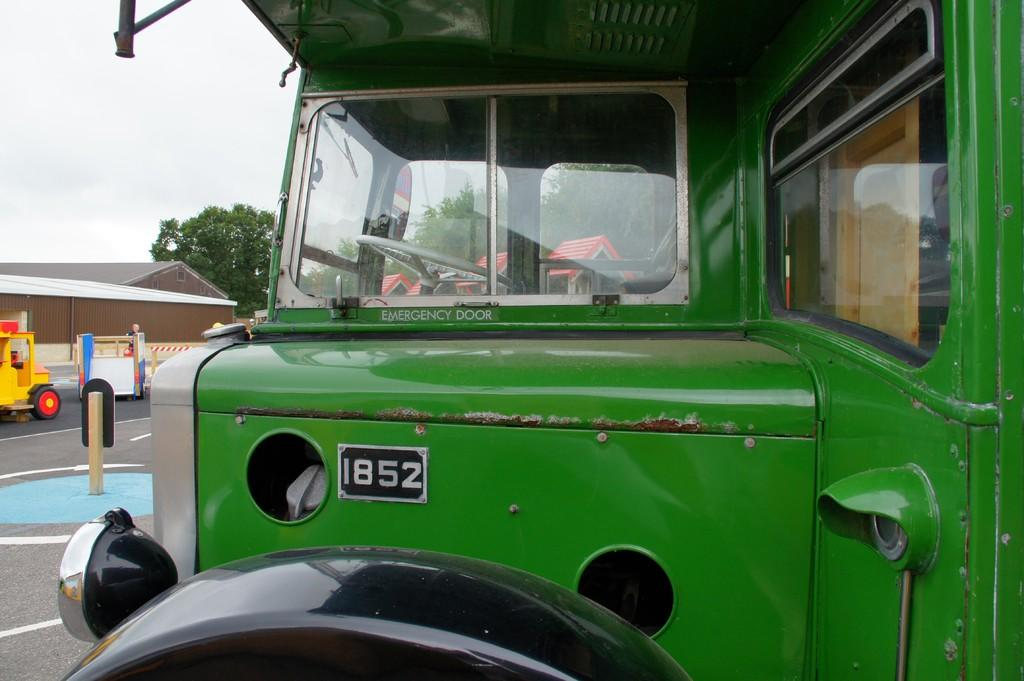What is the main subject in the center of the image? There is a truck in the center of the image. On which side of the image is the truck located? The truck is on the left side of the image. What else can be seen on the road in the image? There is a vehicle visible on the road. What is the board used for in the image? The purpose of the board is not specified in the image. What can be seen in the background of the image? There are sheds, trees, and the sky visible in the background. What type of drink is being served at the governor's event in the image? There is no governor or event present in the image, and therefore no such activity can be observed. 